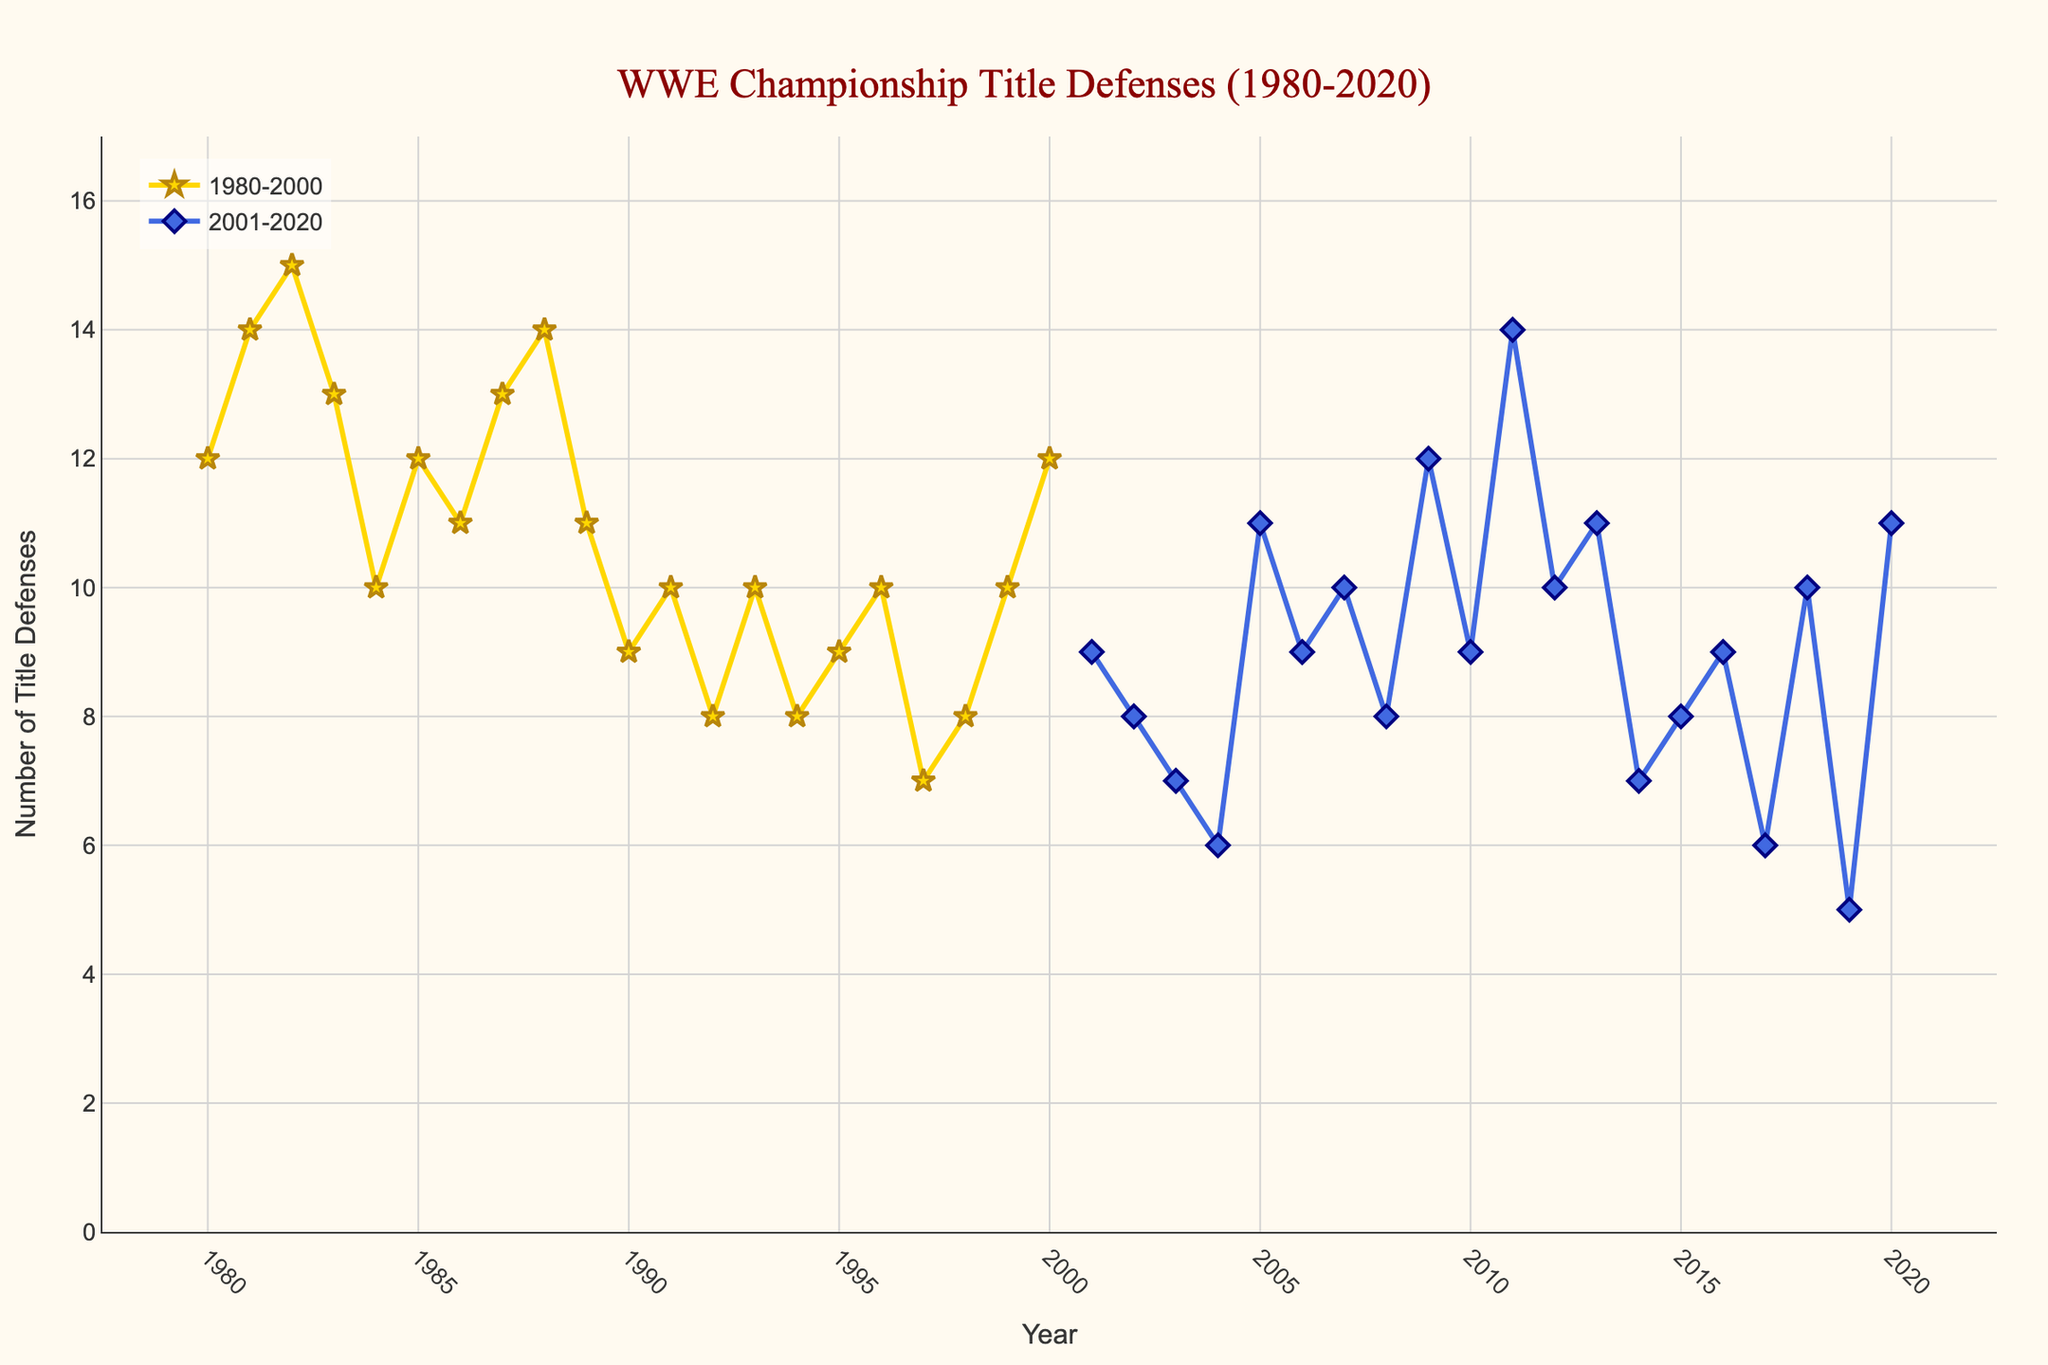How many title defenses did Bob Backlund have in 1981? We look at the data point for the year 1981 where Bob Backlund was the champion, which shows 14 title defenses.
Answer: 14 What was the average number of title defenses for champions during the years 1980 to 2000? To find the average, add all the title defenses from 1980 to 2000 and divide by the number of years. Sum = 12 + 14 + 15 + 13 + 10 + 12 + 11 + 13 + 14 + 11 + 9 + 10 + 8 + 10 + 8 + 9 + 10 + 7 + 8 + 10 + 12 = 226. Number of years = 21. So the average is 226/21 ≈ 10.76.
Answer: 10.76 Who had the maximum number of title defenses in the 2001-2020 period, and how many did they have? From the data, CM Punk had the maximum in 2011 with 14 title defenses.
Answer: CM Punk, 14 In which year did Ric Flair have the fewest title defenses, and how many were there? In 1992, Ric Flair had the fewest title defenses, and the data shows 8 defenses.
Answer: 1992, 8 Compare the title defenses of Hulk Hogan and John Cena. Who had more, and by how many? Summing up Hulk Hogan's defenses: 10 + 12 + 11 + 13 + 11 + 10 = 67. Summing up John Cena's defenses: 11 + 12 + 11 = 34. Hulk Hogan had more with a difference of 67 - 34 = 33.
Answer: Hulk Hogan, 33 What patterns can you observe in the frequency of title defenses from the late 1980s to the early 1990s? Observing the plot, title defenses generally fluctuate between 8 and 15 defenses a year with no strong linear trend but a bit of a decline towards the early 1990s.
Answer: Fluctuating, slight decline How many champions had fewer than 10 title defenses in 2001-2020? Counting entries with title defenses below 10 in the period 2001-2020: Stone Cold Steve Austin (9), Brock Lesnar (8, 7, 6, 5), Kurt Angle (7), Eddie Guerrero (6), Edge (9), Randy Orton (9), CM Punk (10), Seth Rollins (8), AJ Styles (9), and Drew McIntyre (11). There are 9 below 10.
Answer: 9 Which era had generally more title defenses per year, 1980-2000 or 2001-2020? By observing the trend lines in the figure, the 1980-2000 period had generally more frequent title defenses compared to the 2001-2020 period where the trend line is lower on average.
Answer: 1980-2000 Is there a visible trend in the number of title defenses over the entire timeframe from 1980 to 2020? The plot shows no consistent increasing or decreasing trend; rather, it sees fluctuations with periods of higher and lower defenses spread across the timeline.
Answer: No consistent trend 